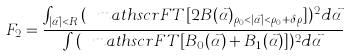Convert formula to latex. <formula><loc_0><loc_0><loc_500><loc_500>F _ { 2 } = \frac { \int _ { | \vec { \alpha } | < R } { ( \ m a t h s c r { F T } [ 2 B ( \vec { \alpha } ) _ { \rho _ { 0 } < | \vec { \alpha } | < \rho _ { 0 } + \delta \rho } ] ) ^ { 2 } } { d } { \vec { \alpha } } } { \int { ( \ m a t h s c r { F T } [ B _ { 0 } ( \vec { \alpha } ) + B _ { 1 } ( \vec { \alpha } ) ] ) ^ { 2 } } { d } { \vec { \alpha } } }</formula> 